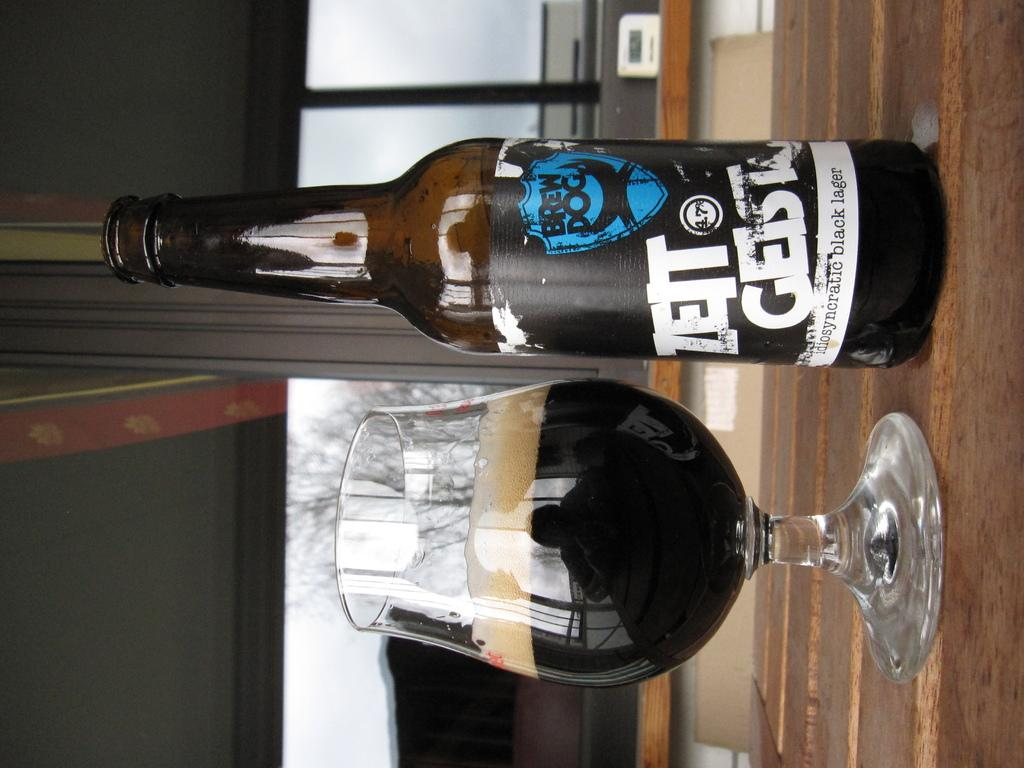What is on the bottle that is visible in the image? There is a label on the bottle in the image. Where is the bottle located in the image? The bottle is on a table in the image. What is in the glass that is visible in the image? There is a drink in the glass in the image. Where is the glass located in the image? The glass is on a table in the image. What type of error can be seen on the badge in the image? There is no badge present in the image, so it is not possible to determine if there is an error on it. 